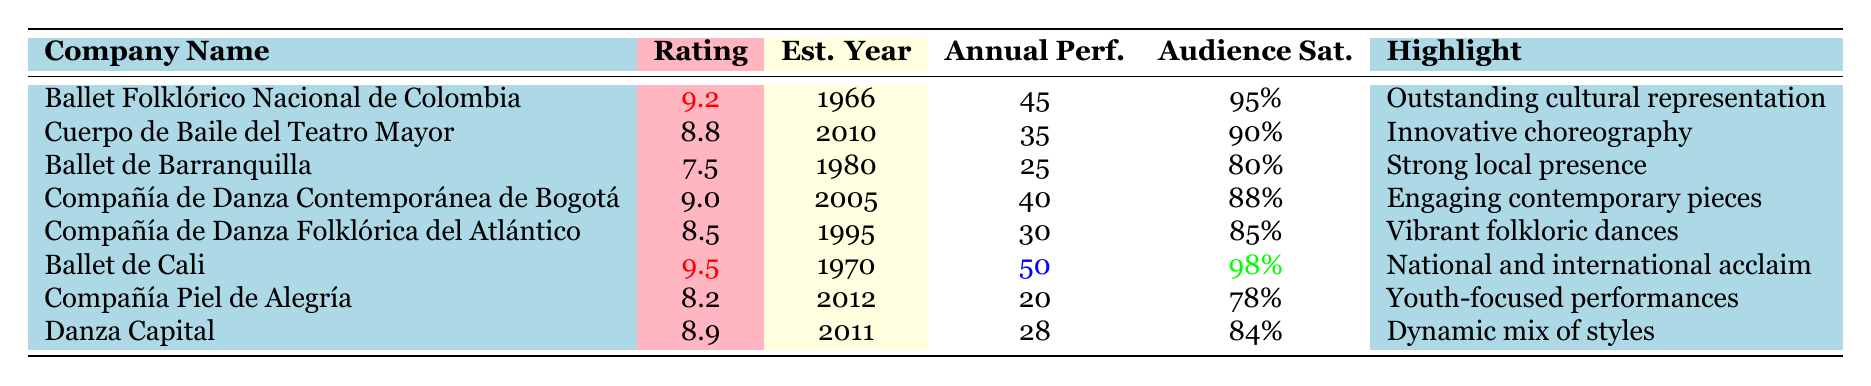What is the highest rating achieved by a dance company? The highest rating is found in the table among the ratings. The values are 9.2, 8.8, 7.5, 9.0, 8.5, 9.5, 8.2, and 8.9. The maximum value is 9.5, achieved by Ballet de Cali.
Answer: 9.5 Which dance company has the highest audience satisfaction? The audience satisfaction percentages for each company are 95%, 90%, 80%, 88%, 85%, 98%, 78%, and 84%. The highest value is 98%, which belongs to Ballet de Cali.
Answer: 98% How many annual performances does Ballet Folklórico Nacional de Colombia give? The table lists Ballet Folklórico Nacional de Colombia under the Annual Performances column, which shows the value as 45.
Answer: 45 What is the average rating of all the dance companies? The ratings are 9.2, 8.8, 7.5, 9.0, 8.5, 9.5, 8.2, and 8.9. Summing these gives 69.6 and there are 8 companies, so the average is 69.6 / 8 = 8.7.
Answer: 8.7 Is Cuerpo de Baile del Teatro Mayor established before 2015? Cuerpo de Baile del Teatro Mayor was established in 2010, which is before 2015. Therefore, the fact is true.
Answer: Yes Which company has a rating lower than 8.5? Looking at the ratings, Ballet de Barranquilla has 7.5 and Compañía Piel de Alegría has 8.2. Both ratings are lower than 8.5.
Answer: Ballet de Barranquilla and Compañía Piel de Alegría What is the difference in audience satisfaction between the company with the highest rating and the company with the lowest rating? The highest audience satisfaction is 98% (Ballet de Cali) and the lowest is 78% (Compañía Piel de Alegría). The difference is 98% - 78% = 20%.
Answer: 20% Which company has been established the longest? Ballet Folklórico Nacional de Colombia was established in 1966, while the others were established later. Therefore, it is the longest established.
Answer: Ballet Folklórico Nacional de Colombia How many companies performed more than 40 annual performances? The dance companies with more than 40 performances are Ballet de Cali (50) and Ballet Folklórico Nacional de Colombia (45). So there are 2 companies.
Answer: 2 Is the average number of annual performances higher than 30? The total annual performances are 45 + 35 + 25 + 40 + 30 + 50 + 20 + 28 = 273. There are 8 companies, so the average is 273 / 8 = 34.125, which is higher than 30.
Answer: Yes Which dance company is known for its strong local presence? The highlight for Ballet de Barranquilla mentions a strong local presence. Looking at the table, it clearly identifies this company.
Answer: Ballet de Barranquilla 